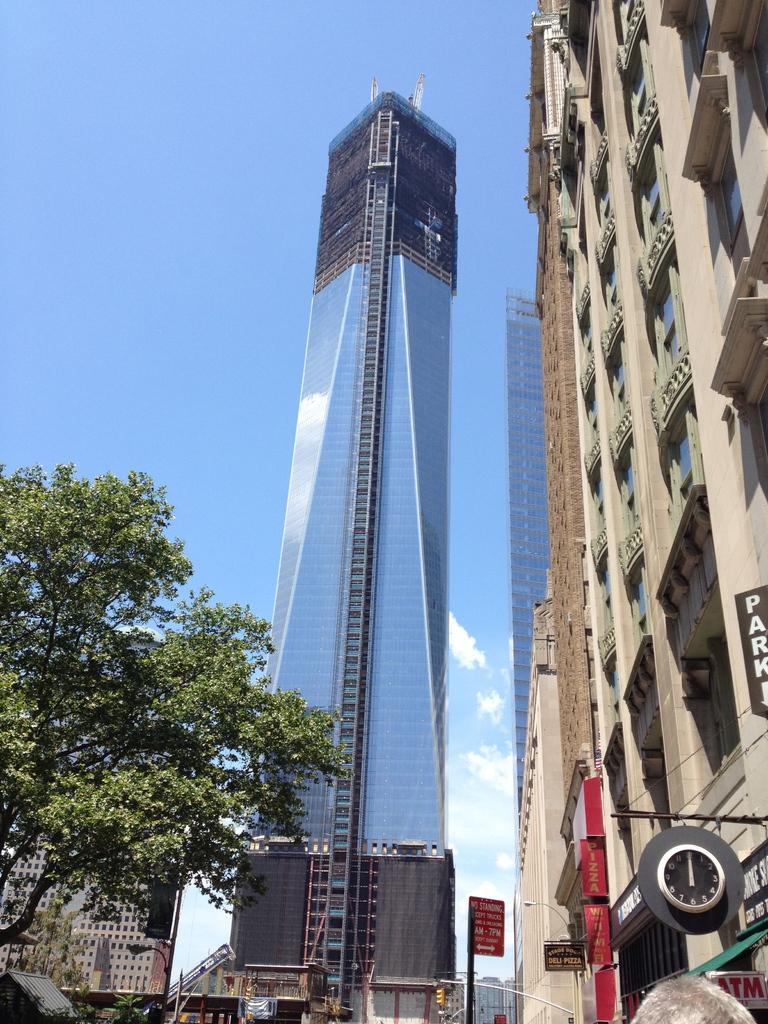In one or two sentences, can you explain what this image depicts? This image is taken outdoors. At the top of the image there is the sky with clouds. On the left side of the image there is a tree and there are a few buildings. In the middle of the image there is a skyscraper. On the right side of the image there are a few buildings and houses. There are a few boards with text on them and there is a clock. 